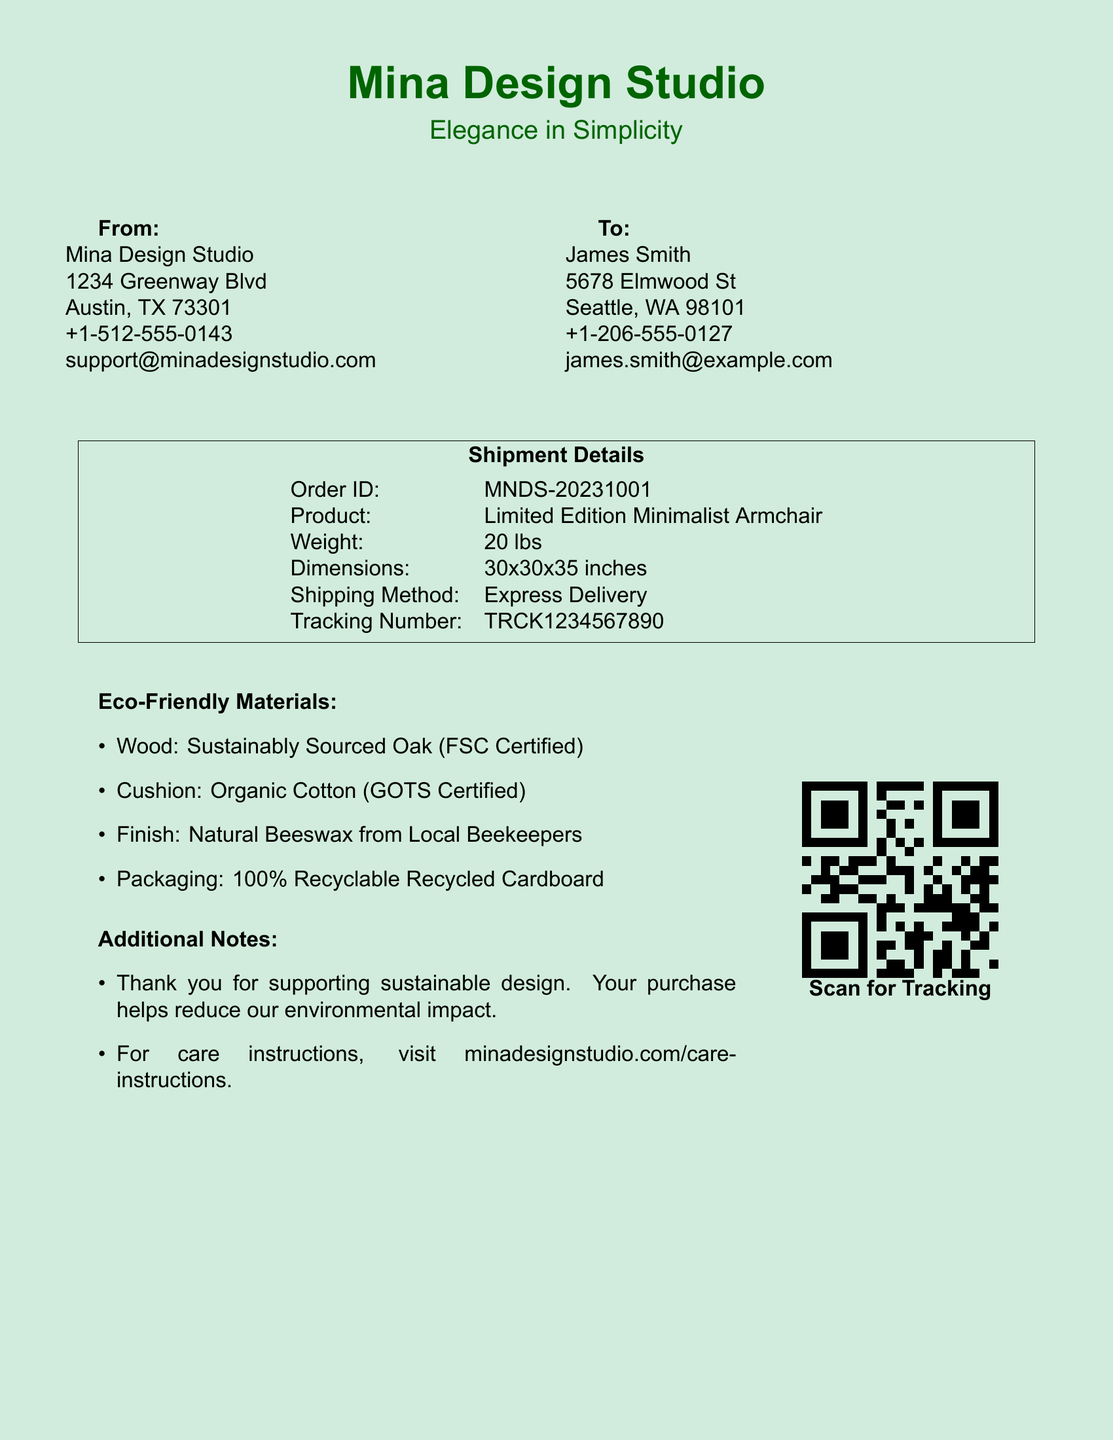What is the product? The product listed in the shipment details is the "Limited Edition Minimalist Armchair."
Answer: Limited Edition Minimalist Armchair What is the weight of the product? The weight is specified in the shipment details as 20 lbs.
Answer: 20 lbs Who is the recipient? The recipient’s name is presented in the "To:" section, which is "James Smith."
Answer: James Smith What materials are used in the cushion? The eco-friendly materials section states that the cushion is made from Organic Cotton.
Answer: Organic Cotton What is the order ID? The order ID is provided in the shipment details as "MNDS-20231001."
Answer: MNDS-20231001 What type of delivery is used? The shipping method mentioned is "Express Delivery."
Answer: Express Delivery What organization certifies the wood used? The document specifies that the wood is "FSC Certified."
Answer: FSC Certified How is the packaging described? In the eco-friendly materials section, the packaging is described as "100% Recyclable Recycled Cardboard."
Answer: 100% Recyclable Recycled Cardboard What is the contact number for Mina Design Studio? The contact number is provided in the "From:" section as "+1-512-555-0143."
Answer: +1-512-555-0143 